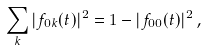<formula> <loc_0><loc_0><loc_500><loc_500>\sum _ { k } | f _ { 0 k } ( t ) | ^ { 2 } = 1 - | f _ { 0 0 } ( t ) | ^ { 2 } \, ,</formula> 